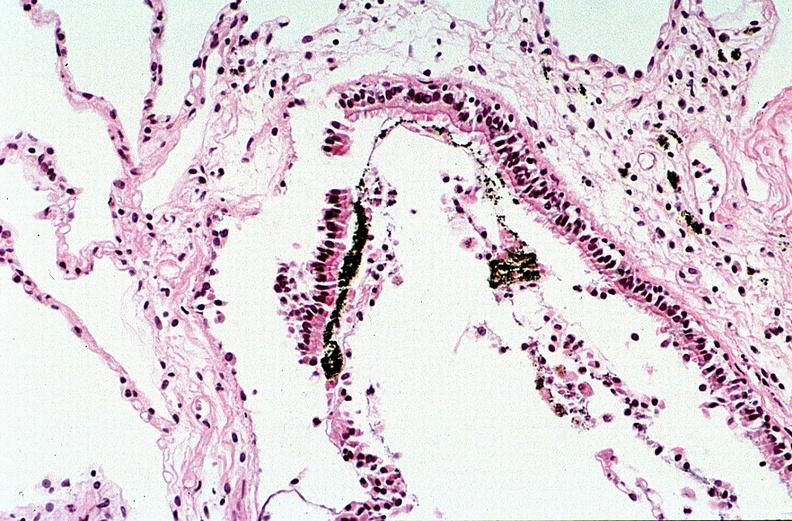what does this image show?
Answer the question using a single word or phrase. Thermal burn 